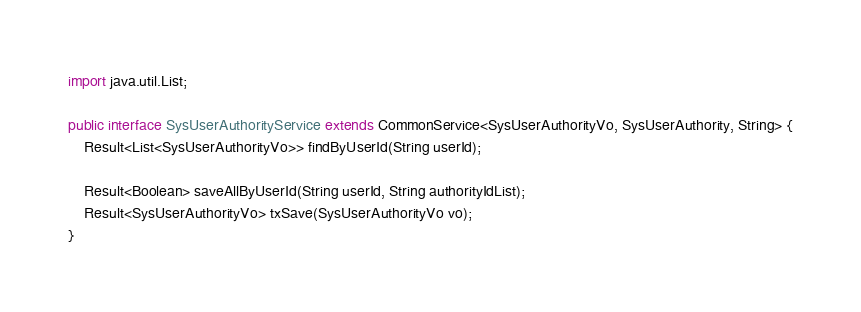Convert code to text. <code><loc_0><loc_0><loc_500><loc_500><_Java_>
import java.util.List;

public interface SysUserAuthorityService extends CommonService<SysUserAuthorityVo, SysUserAuthority, String> {
    Result<List<SysUserAuthorityVo>> findByUserId(String userId);

    Result<Boolean> saveAllByUserId(String userId, String authorityIdList);
    Result<SysUserAuthorityVo> txSave(SysUserAuthorityVo vo);
}
</code> 